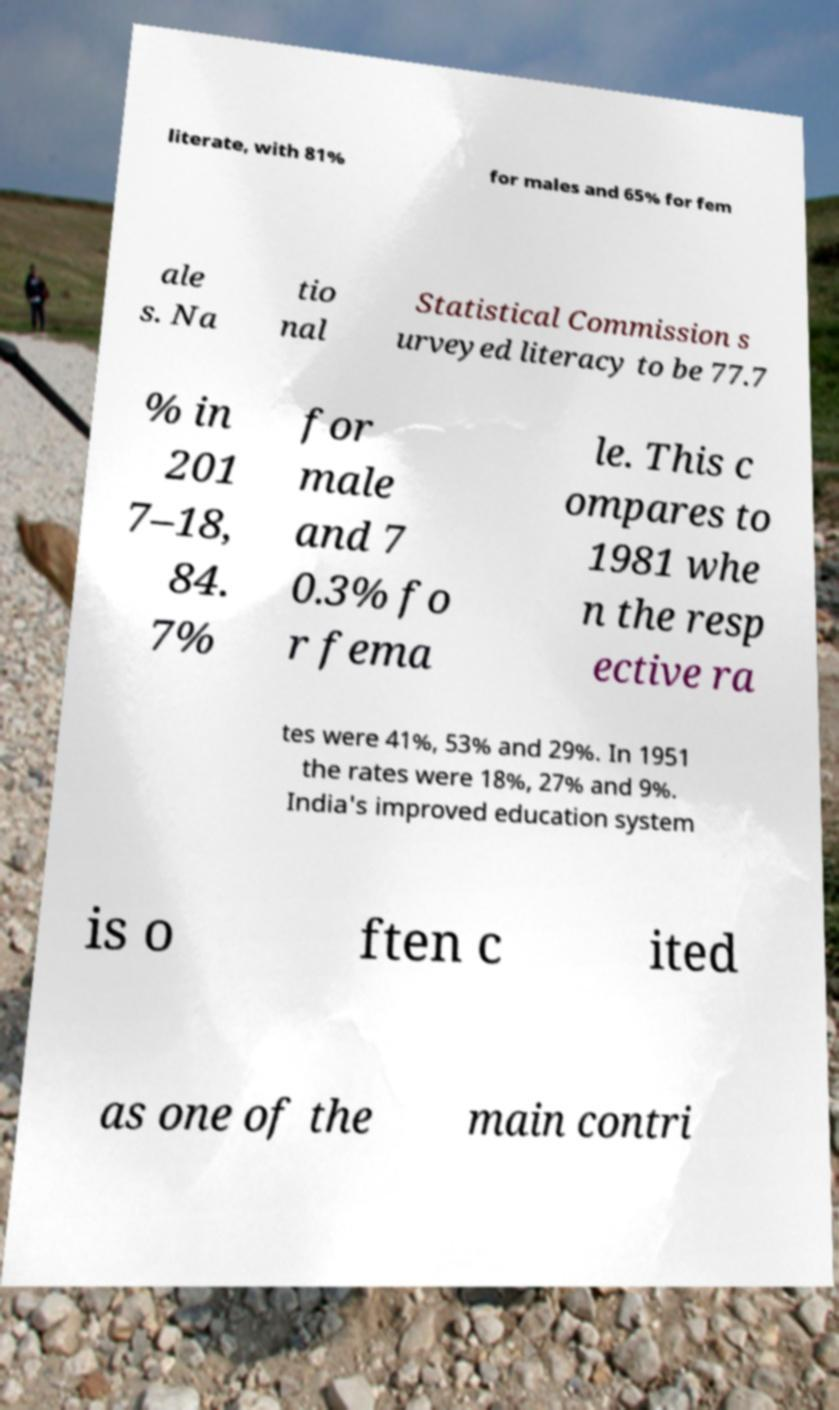What messages or text are displayed in this image? I need them in a readable, typed format. literate, with 81% for males and 65% for fem ale s. Na tio nal Statistical Commission s urveyed literacy to be 77.7 % in 201 7–18, 84. 7% for male and 7 0.3% fo r fema le. This c ompares to 1981 whe n the resp ective ra tes were 41%, 53% and 29%. In 1951 the rates were 18%, 27% and 9%. India's improved education system is o ften c ited as one of the main contri 